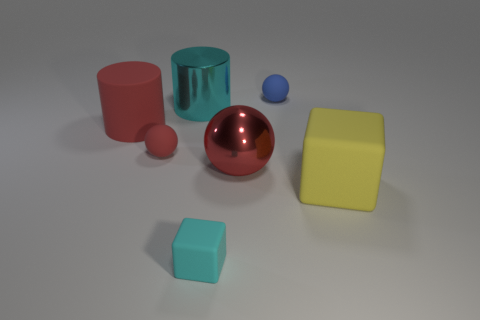Is the number of tiny red spheres that are on the right side of the blue object greater than the number of large metallic objects that are on the right side of the tiny red object?
Make the answer very short. No. How many metal objects are small cyan blocks or large purple balls?
Offer a terse response. 0. There is a small sphere that is the same color as the big metallic sphere; what is its material?
Your answer should be compact. Rubber. Are there fewer red cylinders in front of the blue thing than large red metal spheres that are on the right side of the big red cylinder?
Make the answer very short. No. What number of things are either big metal cylinders or red things that are on the left side of the large red shiny thing?
Provide a succinct answer. 3. There is a red cylinder that is the same size as the red metal thing; what is its material?
Provide a succinct answer. Rubber. Is the small blue ball made of the same material as the large cyan cylinder?
Give a very brief answer. No. What is the color of the thing that is behind the small cyan block and in front of the metallic sphere?
Offer a very short reply. Yellow. There is a large cylinder left of the large cyan cylinder; is it the same color as the metallic cylinder?
Your answer should be very brief. No. There is a blue object that is the same size as the cyan block; what is its shape?
Ensure brevity in your answer.  Sphere. 